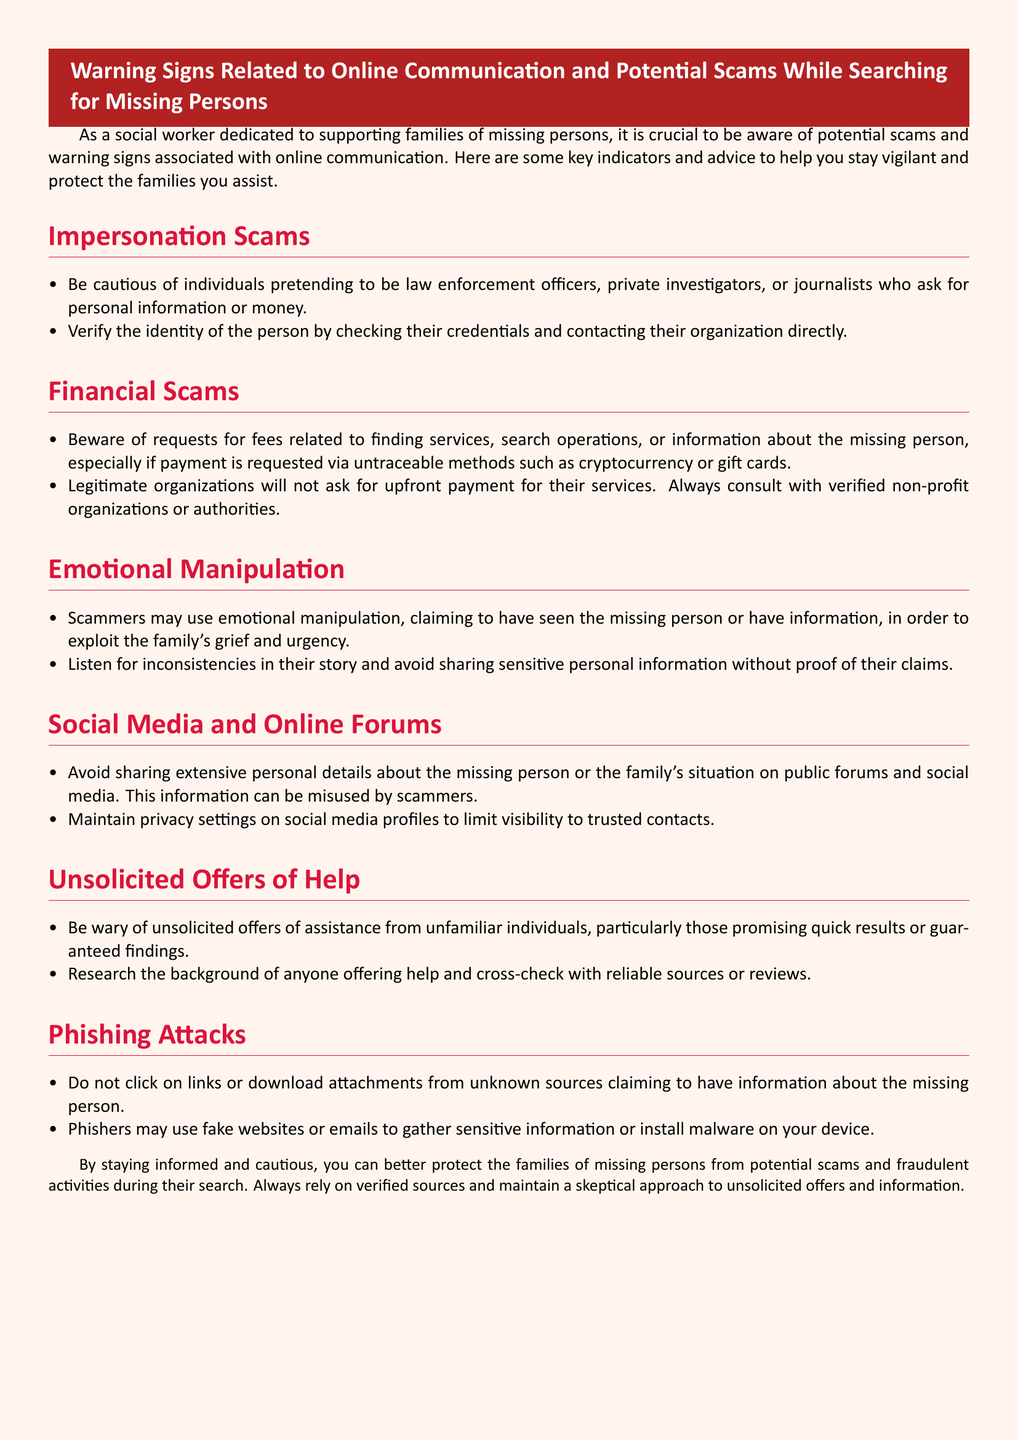What are impersonation scams? Impersonation scams are when individuals pretend to be law enforcement officers, private investigators, or journalists asking for personal information or money.
Answer: Individuals pretending What should you verify when approached by someone claiming to be a professional helper? You should verify the identity of the person by checking their credentials and contacting their organization directly.
Answer: Their identity What payment methods should you be cautious of? Be cautious of payments requested via untraceable methods such as cryptocurrency or gift cards.
Answer: Cryptocurrency or gift cards What is a key indicator of emotional manipulation? A key indicator is when scammers exploit the family's grief and urgency, claiming to have seen the missing person or have information.
Answer: Exploit grief What should you avoid sharing on public forums and social media? You should avoid sharing extensive personal details about the missing person or the family's situation.
Answer: Extensive personal details What do phishing attacks use to gather sensitive information? Phishing attacks may use fake websites or emails to gather sensitive information or install malware.
Answer: Fake websites or emails What type of offers should you be wary of? You should be wary of unsolicited offers of assistance from unfamiliar individuals promising quick results or guaranteed findings.
Answer: Unsolicited offers What is the main purpose of the document? The main purpose is to provide warning signs related to online communication and potential scams while searching for missing persons.
Answer: Warning signs How can families protect themselves from scams? Families can protect themselves by staying informed and cautious, relying on verified sources, and maintaining a skeptical approach to unsolicited offers and information.
Answer: Staying informed and cautious 